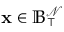Convert formula to latex. <formula><loc_0><loc_0><loc_500><loc_500>x \in \mathbb { B } _ { \intercal } ^ { \mathcal { N } }</formula> 